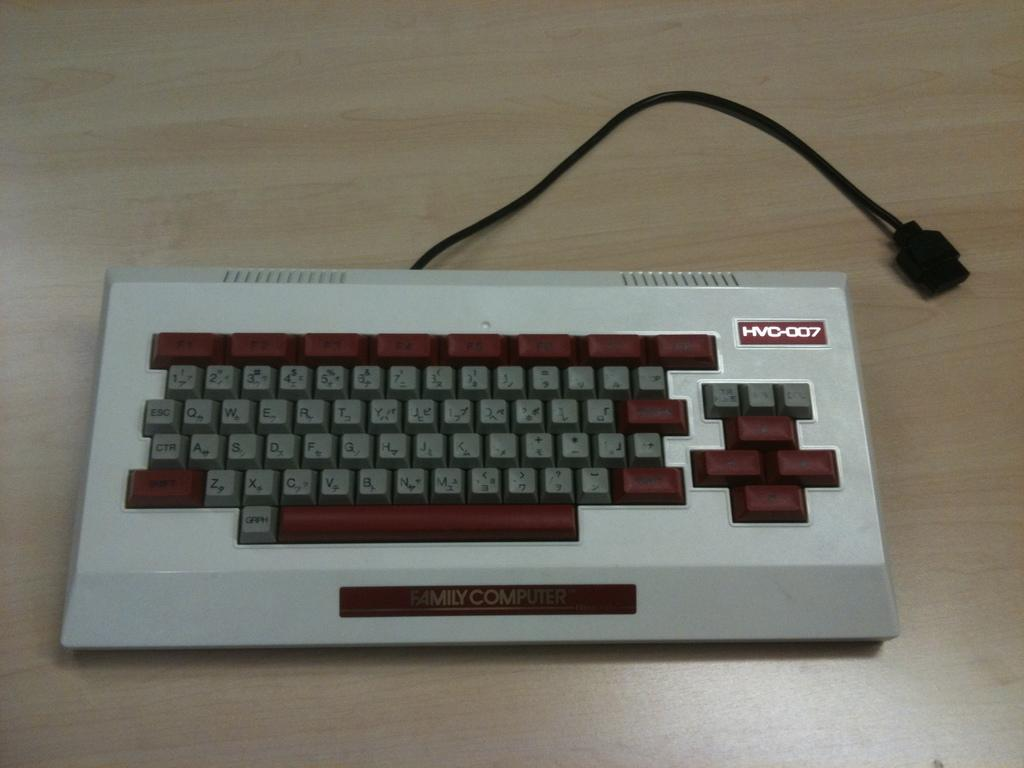What is the main object in the image? There is a keyboard in the image. What can be seen connected to the keyboard? There is a wire in the image. What is written or printed on the keyboard? There is text on the keyboard. What type of surface is visible at the bottom of the image? There is a wooden surface at the bottom of the image. How many dogs are sitting on the keyboard in the image? There are no dogs present in the image; it only features a keyboard, a wire, text, and a wooden surface. 